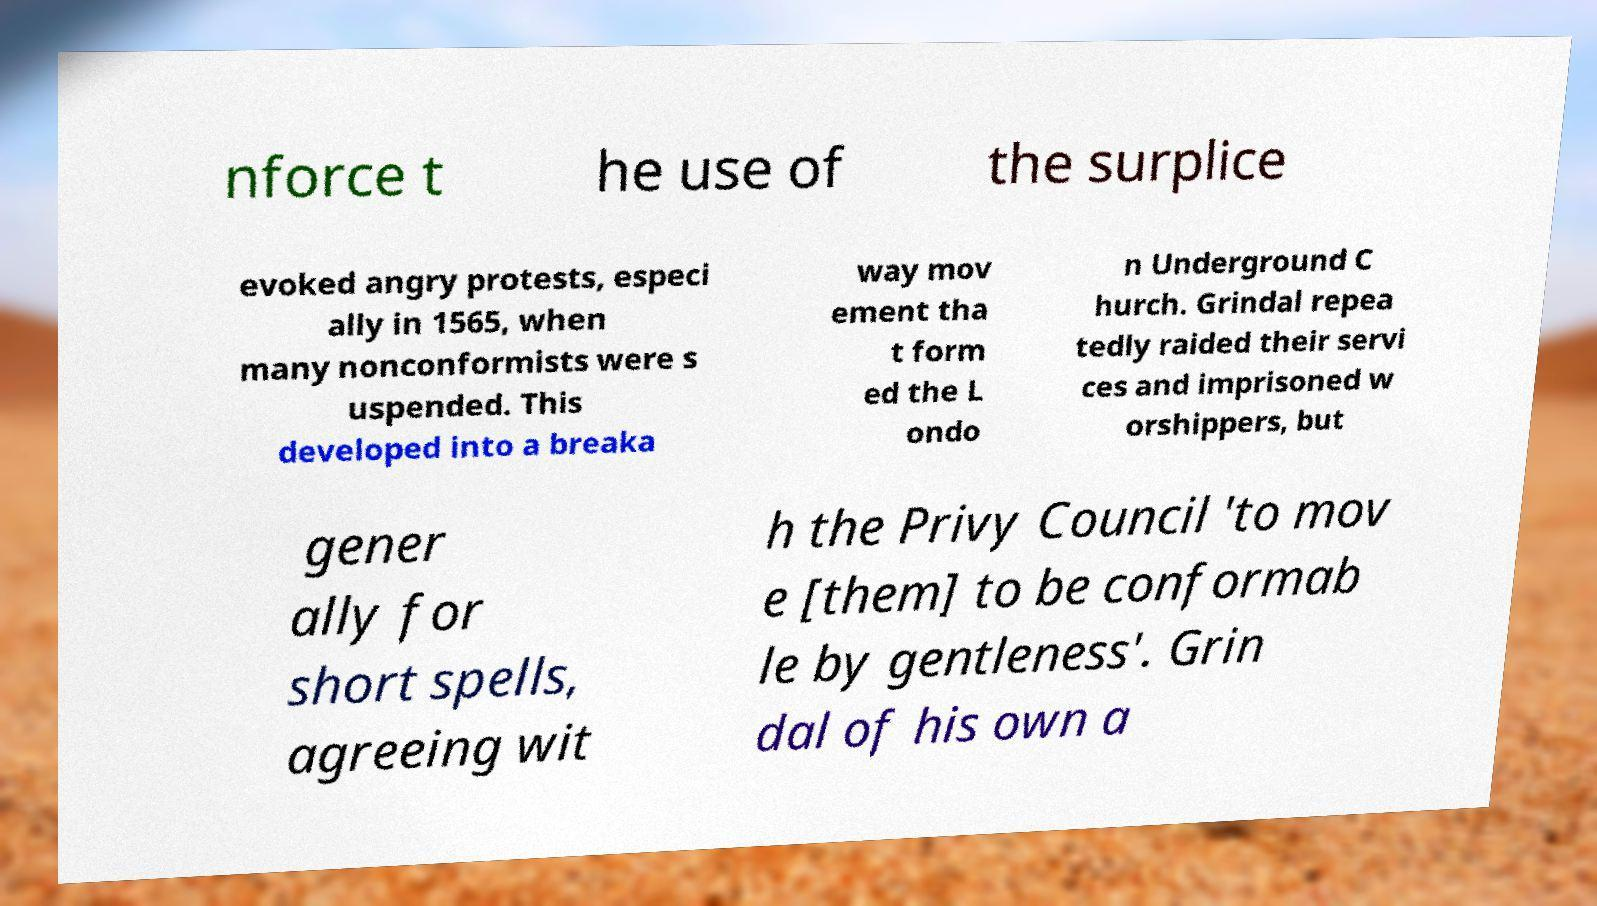Can you read and provide the text displayed in the image?This photo seems to have some interesting text. Can you extract and type it out for me? nforce t he use of the surplice evoked angry protests, especi ally in 1565, when many nonconformists were s uspended. This developed into a breaka way mov ement tha t form ed the L ondo n Underground C hurch. Grindal repea tedly raided their servi ces and imprisoned w orshippers, but gener ally for short spells, agreeing wit h the Privy Council 'to mov e [them] to be conformab le by gentleness'. Grin dal of his own a 